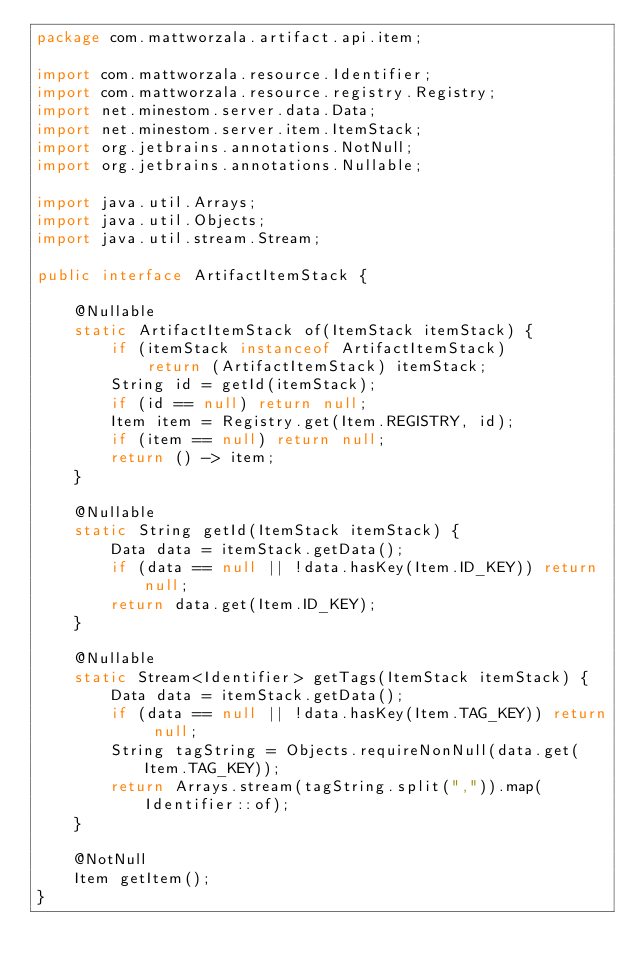Convert code to text. <code><loc_0><loc_0><loc_500><loc_500><_Java_>package com.mattworzala.artifact.api.item;

import com.mattworzala.resource.Identifier;
import com.mattworzala.resource.registry.Registry;
import net.minestom.server.data.Data;
import net.minestom.server.item.ItemStack;
import org.jetbrains.annotations.NotNull;
import org.jetbrains.annotations.Nullable;

import java.util.Arrays;
import java.util.Objects;
import java.util.stream.Stream;

public interface ArtifactItemStack {

    @Nullable
    static ArtifactItemStack of(ItemStack itemStack) {
        if (itemStack instanceof ArtifactItemStack)
            return (ArtifactItemStack) itemStack;
        String id = getId(itemStack);
        if (id == null) return null;
        Item item = Registry.get(Item.REGISTRY, id);
        if (item == null) return null;
        return () -> item;
    }

    @Nullable
    static String getId(ItemStack itemStack) {
        Data data = itemStack.getData();
        if (data == null || !data.hasKey(Item.ID_KEY)) return null;
        return data.get(Item.ID_KEY);
    }

    @Nullable
    static Stream<Identifier> getTags(ItemStack itemStack) {
        Data data = itemStack.getData();
        if (data == null || !data.hasKey(Item.TAG_KEY)) return null;
        String tagString = Objects.requireNonNull(data.get(Item.TAG_KEY));
        return Arrays.stream(tagString.split(",")).map(Identifier::of);
    }

    @NotNull
    Item getItem();
}
</code> 